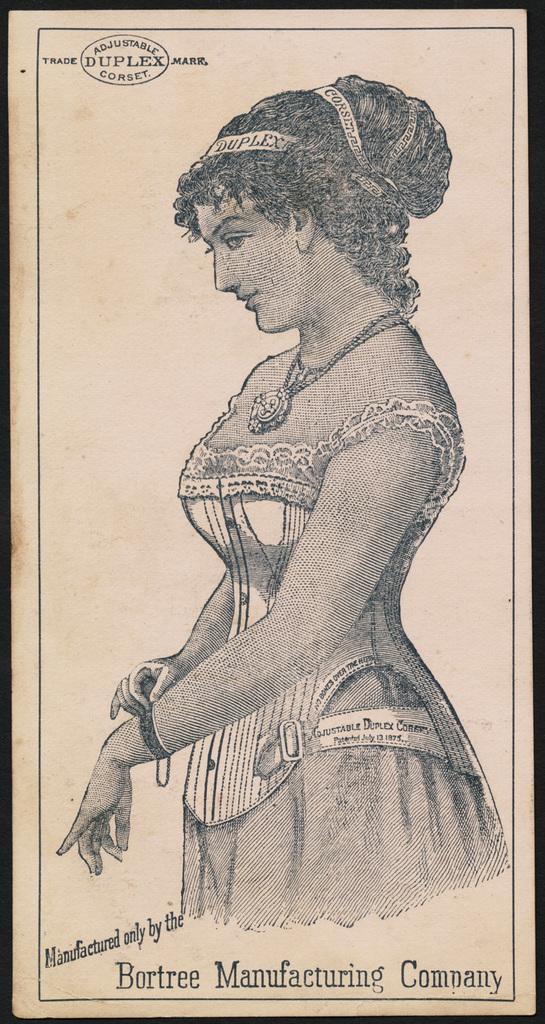Describe this image in one or two sentences. In the center of the image we can see a sketch of a lady on the paper. At the top and bottom there is text. 